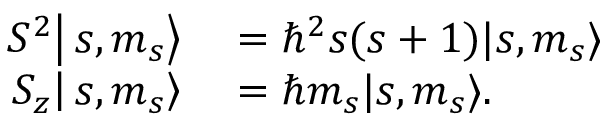Convert formula to latex. <formula><loc_0><loc_0><loc_500><loc_500>\begin{array} { r l } { S ^ { 2 } \right | s , m _ { s } \right \rangle } & = \hbar { ^ } { 2 } s ( s + 1 ) | s , m _ { s } \rangle } \\ { S _ { z } \right | s , m _ { s } \right \rangle } & = \hbar { m } _ { s } | s , m _ { s } \rangle . } \end{array}</formula> 